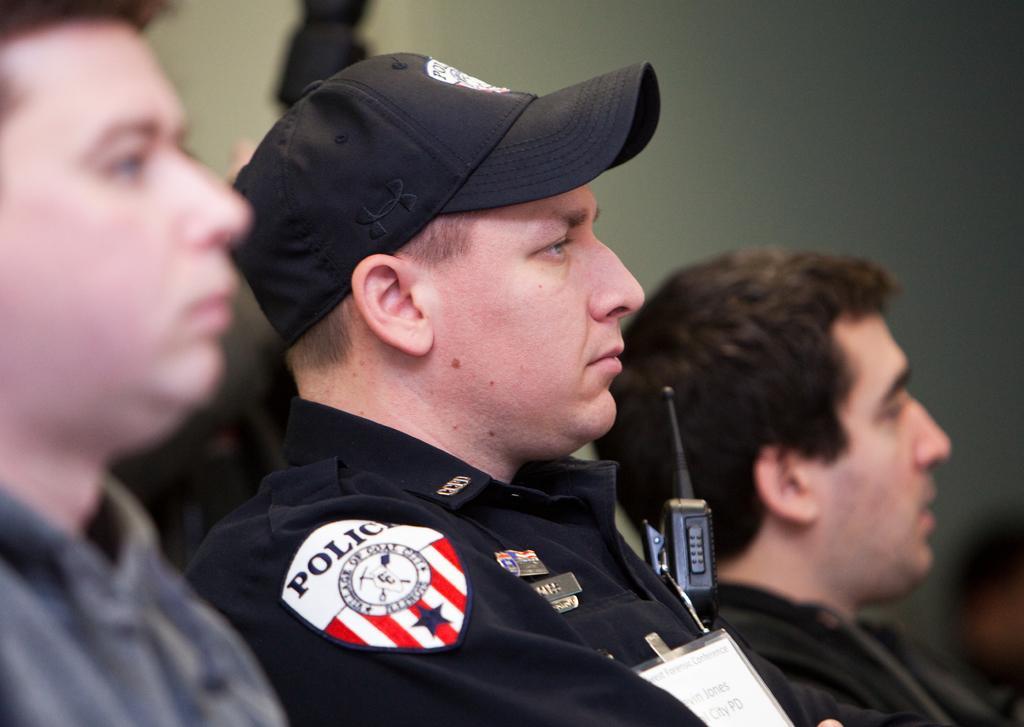How would you summarize this image in a sentence or two? In this image I can see few people are wearing different color dresses. Background is blurred. 